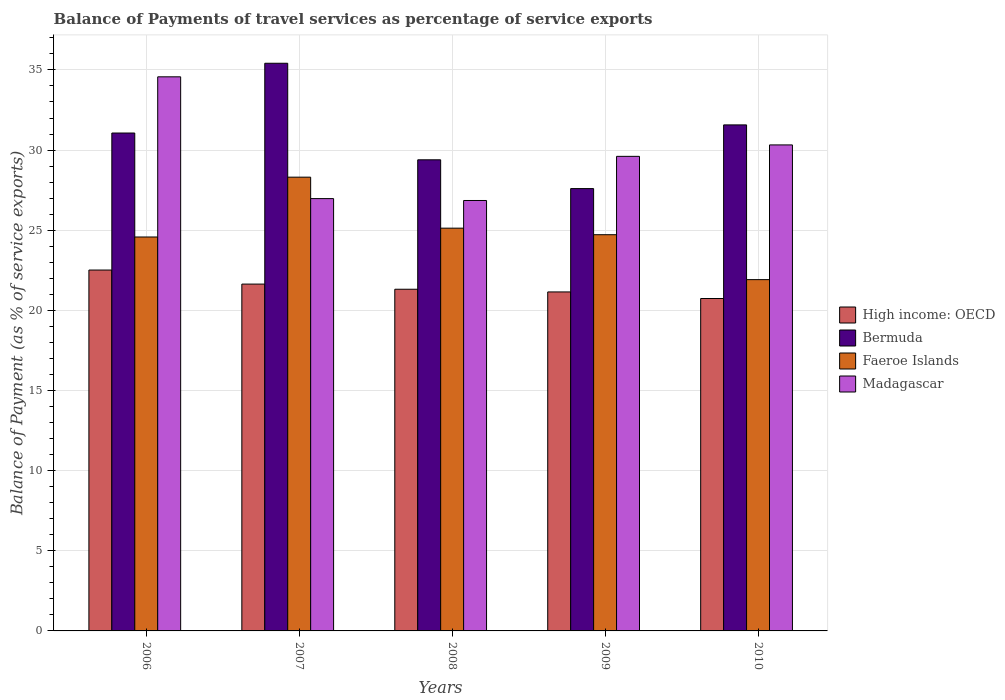How many groups of bars are there?
Provide a succinct answer. 5. What is the balance of payments of travel services in High income: OECD in 2008?
Your response must be concise. 21.32. Across all years, what is the maximum balance of payments of travel services in Madagascar?
Offer a very short reply. 34.57. Across all years, what is the minimum balance of payments of travel services in Faeroe Islands?
Ensure brevity in your answer.  21.92. In which year was the balance of payments of travel services in Bermuda maximum?
Give a very brief answer. 2007. In which year was the balance of payments of travel services in Faeroe Islands minimum?
Your answer should be compact. 2010. What is the total balance of payments of travel services in Faeroe Islands in the graph?
Make the answer very short. 124.65. What is the difference between the balance of payments of travel services in Bermuda in 2008 and that in 2010?
Provide a succinct answer. -2.18. What is the difference between the balance of payments of travel services in Bermuda in 2007 and the balance of payments of travel services in Faeroe Islands in 2009?
Your answer should be compact. 10.7. What is the average balance of payments of travel services in High income: OECD per year?
Your response must be concise. 21.47. In the year 2007, what is the difference between the balance of payments of travel services in Bermuda and balance of payments of travel services in Madagascar?
Make the answer very short. 8.44. What is the ratio of the balance of payments of travel services in Bermuda in 2006 to that in 2009?
Ensure brevity in your answer.  1.13. What is the difference between the highest and the second highest balance of payments of travel services in Madagascar?
Make the answer very short. 4.25. What is the difference between the highest and the lowest balance of payments of travel services in High income: OECD?
Provide a succinct answer. 1.78. In how many years, is the balance of payments of travel services in Faeroe Islands greater than the average balance of payments of travel services in Faeroe Islands taken over all years?
Your response must be concise. 2. What does the 3rd bar from the left in 2006 represents?
Provide a succinct answer. Faeroe Islands. What does the 1st bar from the right in 2006 represents?
Keep it short and to the point. Madagascar. How many bars are there?
Offer a very short reply. 20. How many years are there in the graph?
Offer a terse response. 5. Does the graph contain any zero values?
Ensure brevity in your answer.  No. Where does the legend appear in the graph?
Offer a very short reply. Center right. How many legend labels are there?
Make the answer very short. 4. What is the title of the graph?
Your answer should be compact. Balance of Payments of travel services as percentage of service exports. Does "Maldives" appear as one of the legend labels in the graph?
Your answer should be very brief. No. What is the label or title of the X-axis?
Give a very brief answer. Years. What is the label or title of the Y-axis?
Keep it short and to the point. Balance of Payment (as % of service exports). What is the Balance of Payment (as % of service exports) of High income: OECD in 2006?
Make the answer very short. 22.52. What is the Balance of Payment (as % of service exports) of Bermuda in 2006?
Ensure brevity in your answer.  31.06. What is the Balance of Payment (as % of service exports) of Faeroe Islands in 2006?
Provide a succinct answer. 24.58. What is the Balance of Payment (as % of service exports) of Madagascar in 2006?
Ensure brevity in your answer.  34.57. What is the Balance of Payment (as % of service exports) in High income: OECD in 2007?
Your answer should be compact. 21.64. What is the Balance of Payment (as % of service exports) of Bermuda in 2007?
Your response must be concise. 35.42. What is the Balance of Payment (as % of service exports) of Faeroe Islands in 2007?
Offer a very short reply. 28.31. What is the Balance of Payment (as % of service exports) of Madagascar in 2007?
Your answer should be very brief. 26.97. What is the Balance of Payment (as % of service exports) of High income: OECD in 2008?
Give a very brief answer. 21.32. What is the Balance of Payment (as % of service exports) in Bermuda in 2008?
Keep it short and to the point. 29.39. What is the Balance of Payment (as % of service exports) of Faeroe Islands in 2008?
Your answer should be very brief. 25.13. What is the Balance of Payment (as % of service exports) of Madagascar in 2008?
Your response must be concise. 26.86. What is the Balance of Payment (as % of service exports) of High income: OECD in 2009?
Offer a terse response. 21.15. What is the Balance of Payment (as % of service exports) of Bermuda in 2009?
Make the answer very short. 27.6. What is the Balance of Payment (as % of service exports) in Faeroe Islands in 2009?
Ensure brevity in your answer.  24.72. What is the Balance of Payment (as % of service exports) of Madagascar in 2009?
Your response must be concise. 29.61. What is the Balance of Payment (as % of service exports) of High income: OECD in 2010?
Keep it short and to the point. 20.74. What is the Balance of Payment (as % of service exports) in Bermuda in 2010?
Your response must be concise. 31.57. What is the Balance of Payment (as % of service exports) of Faeroe Islands in 2010?
Your response must be concise. 21.92. What is the Balance of Payment (as % of service exports) of Madagascar in 2010?
Provide a succinct answer. 30.32. Across all years, what is the maximum Balance of Payment (as % of service exports) in High income: OECD?
Make the answer very short. 22.52. Across all years, what is the maximum Balance of Payment (as % of service exports) in Bermuda?
Your response must be concise. 35.42. Across all years, what is the maximum Balance of Payment (as % of service exports) of Faeroe Islands?
Offer a very short reply. 28.31. Across all years, what is the maximum Balance of Payment (as % of service exports) in Madagascar?
Ensure brevity in your answer.  34.57. Across all years, what is the minimum Balance of Payment (as % of service exports) of High income: OECD?
Ensure brevity in your answer.  20.74. Across all years, what is the minimum Balance of Payment (as % of service exports) in Bermuda?
Provide a succinct answer. 27.6. Across all years, what is the minimum Balance of Payment (as % of service exports) in Faeroe Islands?
Give a very brief answer. 21.92. Across all years, what is the minimum Balance of Payment (as % of service exports) in Madagascar?
Provide a short and direct response. 26.86. What is the total Balance of Payment (as % of service exports) in High income: OECD in the graph?
Make the answer very short. 107.36. What is the total Balance of Payment (as % of service exports) in Bermuda in the graph?
Make the answer very short. 155.04. What is the total Balance of Payment (as % of service exports) in Faeroe Islands in the graph?
Ensure brevity in your answer.  124.65. What is the total Balance of Payment (as % of service exports) of Madagascar in the graph?
Ensure brevity in your answer.  148.33. What is the difference between the Balance of Payment (as % of service exports) in High income: OECD in 2006 and that in 2007?
Give a very brief answer. 0.88. What is the difference between the Balance of Payment (as % of service exports) in Bermuda in 2006 and that in 2007?
Offer a terse response. -4.35. What is the difference between the Balance of Payment (as % of service exports) in Faeroe Islands in 2006 and that in 2007?
Your answer should be compact. -3.73. What is the difference between the Balance of Payment (as % of service exports) of Madagascar in 2006 and that in 2007?
Provide a succinct answer. 7.6. What is the difference between the Balance of Payment (as % of service exports) of High income: OECD in 2006 and that in 2008?
Provide a succinct answer. 1.2. What is the difference between the Balance of Payment (as % of service exports) of Bermuda in 2006 and that in 2008?
Your answer should be very brief. 1.67. What is the difference between the Balance of Payment (as % of service exports) of Faeroe Islands in 2006 and that in 2008?
Provide a short and direct response. -0.55. What is the difference between the Balance of Payment (as % of service exports) in Madagascar in 2006 and that in 2008?
Offer a terse response. 7.72. What is the difference between the Balance of Payment (as % of service exports) in High income: OECD in 2006 and that in 2009?
Give a very brief answer. 1.37. What is the difference between the Balance of Payment (as % of service exports) of Bermuda in 2006 and that in 2009?
Give a very brief answer. 3.47. What is the difference between the Balance of Payment (as % of service exports) in Faeroe Islands in 2006 and that in 2009?
Offer a very short reply. -0.14. What is the difference between the Balance of Payment (as % of service exports) in Madagascar in 2006 and that in 2009?
Your response must be concise. 4.96. What is the difference between the Balance of Payment (as % of service exports) of High income: OECD in 2006 and that in 2010?
Provide a succinct answer. 1.78. What is the difference between the Balance of Payment (as % of service exports) in Bermuda in 2006 and that in 2010?
Your response must be concise. -0.51. What is the difference between the Balance of Payment (as % of service exports) in Faeroe Islands in 2006 and that in 2010?
Your answer should be very brief. 2.66. What is the difference between the Balance of Payment (as % of service exports) in Madagascar in 2006 and that in 2010?
Offer a very short reply. 4.25. What is the difference between the Balance of Payment (as % of service exports) in High income: OECD in 2007 and that in 2008?
Keep it short and to the point. 0.32. What is the difference between the Balance of Payment (as % of service exports) of Bermuda in 2007 and that in 2008?
Make the answer very short. 6.02. What is the difference between the Balance of Payment (as % of service exports) in Faeroe Islands in 2007 and that in 2008?
Offer a terse response. 3.18. What is the difference between the Balance of Payment (as % of service exports) of Madagascar in 2007 and that in 2008?
Make the answer very short. 0.12. What is the difference between the Balance of Payment (as % of service exports) of High income: OECD in 2007 and that in 2009?
Offer a very short reply. 0.49. What is the difference between the Balance of Payment (as % of service exports) of Bermuda in 2007 and that in 2009?
Make the answer very short. 7.82. What is the difference between the Balance of Payment (as % of service exports) of Faeroe Islands in 2007 and that in 2009?
Keep it short and to the point. 3.59. What is the difference between the Balance of Payment (as % of service exports) in Madagascar in 2007 and that in 2009?
Your answer should be very brief. -2.64. What is the difference between the Balance of Payment (as % of service exports) in High income: OECD in 2007 and that in 2010?
Offer a terse response. 0.9. What is the difference between the Balance of Payment (as % of service exports) in Bermuda in 2007 and that in 2010?
Keep it short and to the point. 3.85. What is the difference between the Balance of Payment (as % of service exports) in Faeroe Islands in 2007 and that in 2010?
Provide a succinct answer. 6.39. What is the difference between the Balance of Payment (as % of service exports) of Madagascar in 2007 and that in 2010?
Offer a very short reply. -3.35. What is the difference between the Balance of Payment (as % of service exports) in High income: OECD in 2008 and that in 2009?
Provide a succinct answer. 0.17. What is the difference between the Balance of Payment (as % of service exports) in Bermuda in 2008 and that in 2009?
Your answer should be very brief. 1.8. What is the difference between the Balance of Payment (as % of service exports) of Faeroe Islands in 2008 and that in 2009?
Offer a very short reply. 0.41. What is the difference between the Balance of Payment (as % of service exports) in Madagascar in 2008 and that in 2009?
Offer a very short reply. -2.75. What is the difference between the Balance of Payment (as % of service exports) of High income: OECD in 2008 and that in 2010?
Your answer should be compact. 0.58. What is the difference between the Balance of Payment (as % of service exports) of Bermuda in 2008 and that in 2010?
Offer a very short reply. -2.18. What is the difference between the Balance of Payment (as % of service exports) in Faeroe Islands in 2008 and that in 2010?
Your answer should be compact. 3.21. What is the difference between the Balance of Payment (as % of service exports) of Madagascar in 2008 and that in 2010?
Make the answer very short. -3.47. What is the difference between the Balance of Payment (as % of service exports) in High income: OECD in 2009 and that in 2010?
Your answer should be very brief. 0.41. What is the difference between the Balance of Payment (as % of service exports) in Bermuda in 2009 and that in 2010?
Make the answer very short. -3.97. What is the difference between the Balance of Payment (as % of service exports) in Faeroe Islands in 2009 and that in 2010?
Ensure brevity in your answer.  2.8. What is the difference between the Balance of Payment (as % of service exports) in Madagascar in 2009 and that in 2010?
Your response must be concise. -0.71. What is the difference between the Balance of Payment (as % of service exports) in High income: OECD in 2006 and the Balance of Payment (as % of service exports) in Bermuda in 2007?
Provide a succinct answer. -12.9. What is the difference between the Balance of Payment (as % of service exports) in High income: OECD in 2006 and the Balance of Payment (as % of service exports) in Faeroe Islands in 2007?
Offer a very short reply. -5.79. What is the difference between the Balance of Payment (as % of service exports) in High income: OECD in 2006 and the Balance of Payment (as % of service exports) in Madagascar in 2007?
Offer a very short reply. -4.46. What is the difference between the Balance of Payment (as % of service exports) in Bermuda in 2006 and the Balance of Payment (as % of service exports) in Faeroe Islands in 2007?
Make the answer very short. 2.75. What is the difference between the Balance of Payment (as % of service exports) in Bermuda in 2006 and the Balance of Payment (as % of service exports) in Madagascar in 2007?
Offer a terse response. 4.09. What is the difference between the Balance of Payment (as % of service exports) of Faeroe Islands in 2006 and the Balance of Payment (as % of service exports) of Madagascar in 2007?
Offer a very short reply. -2.4. What is the difference between the Balance of Payment (as % of service exports) of High income: OECD in 2006 and the Balance of Payment (as % of service exports) of Bermuda in 2008?
Keep it short and to the point. -6.88. What is the difference between the Balance of Payment (as % of service exports) in High income: OECD in 2006 and the Balance of Payment (as % of service exports) in Faeroe Islands in 2008?
Offer a very short reply. -2.61. What is the difference between the Balance of Payment (as % of service exports) in High income: OECD in 2006 and the Balance of Payment (as % of service exports) in Madagascar in 2008?
Your response must be concise. -4.34. What is the difference between the Balance of Payment (as % of service exports) of Bermuda in 2006 and the Balance of Payment (as % of service exports) of Faeroe Islands in 2008?
Your answer should be compact. 5.94. What is the difference between the Balance of Payment (as % of service exports) of Bermuda in 2006 and the Balance of Payment (as % of service exports) of Madagascar in 2008?
Provide a succinct answer. 4.21. What is the difference between the Balance of Payment (as % of service exports) in Faeroe Islands in 2006 and the Balance of Payment (as % of service exports) in Madagascar in 2008?
Your response must be concise. -2.28. What is the difference between the Balance of Payment (as % of service exports) of High income: OECD in 2006 and the Balance of Payment (as % of service exports) of Bermuda in 2009?
Provide a short and direct response. -5.08. What is the difference between the Balance of Payment (as % of service exports) of High income: OECD in 2006 and the Balance of Payment (as % of service exports) of Faeroe Islands in 2009?
Your answer should be very brief. -2.2. What is the difference between the Balance of Payment (as % of service exports) of High income: OECD in 2006 and the Balance of Payment (as % of service exports) of Madagascar in 2009?
Your answer should be compact. -7.09. What is the difference between the Balance of Payment (as % of service exports) of Bermuda in 2006 and the Balance of Payment (as % of service exports) of Faeroe Islands in 2009?
Keep it short and to the point. 6.34. What is the difference between the Balance of Payment (as % of service exports) in Bermuda in 2006 and the Balance of Payment (as % of service exports) in Madagascar in 2009?
Make the answer very short. 1.46. What is the difference between the Balance of Payment (as % of service exports) of Faeroe Islands in 2006 and the Balance of Payment (as % of service exports) of Madagascar in 2009?
Ensure brevity in your answer.  -5.03. What is the difference between the Balance of Payment (as % of service exports) of High income: OECD in 2006 and the Balance of Payment (as % of service exports) of Bermuda in 2010?
Provide a succinct answer. -9.05. What is the difference between the Balance of Payment (as % of service exports) in High income: OECD in 2006 and the Balance of Payment (as % of service exports) in Faeroe Islands in 2010?
Provide a short and direct response. 0.6. What is the difference between the Balance of Payment (as % of service exports) of High income: OECD in 2006 and the Balance of Payment (as % of service exports) of Madagascar in 2010?
Offer a terse response. -7.81. What is the difference between the Balance of Payment (as % of service exports) of Bermuda in 2006 and the Balance of Payment (as % of service exports) of Faeroe Islands in 2010?
Keep it short and to the point. 9.15. What is the difference between the Balance of Payment (as % of service exports) of Bermuda in 2006 and the Balance of Payment (as % of service exports) of Madagascar in 2010?
Provide a short and direct response. 0.74. What is the difference between the Balance of Payment (as % of service exports) of Faeroe Islands in 2006 and the Balance of Payment (as % of service exports) of Madagascar in 2010?
Your answer should be compact. -5.74. What is the difference between the Balance of Payment (as % of service exports) in High income: OECD in 2007 and the Balance of Payment (as % of service exports) in Bermuda in 2008?
Offer a terse response. -7.75. What is the difference between the Balance of Payment (as % of service exports) of High income: OECD in 2007 and the Balance of Payment (as % of service exports) of Faeroe Islands in 2008?
Offer a terse response. -3.49. What is the difference between the Balance of Payment (as % of service exports) of High income: OECD in 2007 and the Balance of Payment (as % of service exports) of Madagascar in 2008?
Make the answer very short. -5.22. What is the difference between the Balance of Payment (as % of service exports) of Bermuda in 2007 and the Balance of Payment (as % of service exports) of Faeroe Islands in 2008?
Ensure brevity in your answer.  10.29. What is the difference between the Balance of Payment (as % of service exports) in Bermuda in 2007 and the Balance of Payment (as % of service exports) in Madagascar in 2008?
Make the answer very short. 8.56. What is the difference between the Balance of Payment (as % of service exports) of Faeroe Islands in 2007 and the Balance of Payment (as % of service exports) of Madagascar in 2008?
Keep it short and to the point. 1.46. What is the difference between the Balance of Payment (as % of service exports) in High income: OECD in 2007 and the Balance of Payment (as % of service exports) in Bermuda in 2009?
Give a very brief answer. -5.96. What is the difference between the Balance of Payment (as % of service exports) in High income: OECD in 2007 and the Balance of Payment (as % of service exports) in Faeroe Islands in 2009?
Ensure brevity in your answer.  -3.08. What is the difference between the Balance of Payment (as % of service exports) in High income: OECD in 2007 and the Balance of Payment (as % of service exports) in Madagascar in 2009?
Your answer should be very brief. -7.97. What is the difference between the Balance of Payment (as % of service exports) of Bermuda in 2007 and the Balance of Payment (as % of service exports) of Faeroe Islands in 2009?
Give a very brief answer. 10.7. What is the difference between the Balance of Payment (as % of service exports) of Bermuda in 2007 and the Balance of Payment (as % of service exports) of Madagascar in 2009?
Your response must be concise. 5.81. What is the difference between the Balance of Payment (as % of service exports) in Faeroe Islands in 2007 and the Balance of Payment (as % of service exports) in Madagascar in 2009?
Make the answer very short. -1.3. What is the difference between the Balance of Payment (as % of service exports) of High income: OECD in 2007 and the Balance of Payment (as % of service exports) of Bermuda in 2010?
Keep it short and to the point. -9.93. What is the difference between the Balance of Payment (as % of service exports) of High income: OECD in 2007 and the Balance of Payment (as % of service exports) of Faeroe Islands in 2010?
Your answer should be very brief. -0.28. What is the difference between the Balance of Payment (as % of service exports) of High income: OECD in 2007 and the Balance of Payment (as % of service exports) of Madagascar in 2010?
Your answer should be compact. -8.68. What is the difference between the Balance of Payment (as % of service exports) in Bermuda in 2007 and the Balance of Payment (as % of service exports) in Madagascar in 2010?
Make the answer very short. 5.09. What is the difference between the Balance of Payment (as % of service exports) in Faeroe Islands in 2007 and the Balance of Payment (as % of service exports) in Madagascar in 2010?
Your answer should be compact. -2.01. What is the difference between the Balance of Payment (as % of service exports) in High income: OECD in 2008 and the Balance of Payment (as % of service exports) in Bermuda in 2009?
Make the answer very short. -6.28. What is the difference between the Balance of Payment (as % of service exports) in High income: OECD in 2008 and the Balance of Payment (as % of service exports) in Faeroe Islands in 2009?
Offer a terse response. -3.4. What is the difference between the Balance of Payment (as % of service exports) in High income: OECD in 2008 and the Balance of Payment (as % of service exports) in Madagascar in 2009?
Ensure brevity in your answer.  -8.29. What is the difference between the Balance of Payment (as % of service exports) in Bermuda in 2008 and the Balance of Payment (as % of service exports) in Faeroe Islands in 2009?
Your answer should be very brief. 4.67. What is the difference between the Balance of Payment (as % of service exports) in Bermuda in 2008 and the Balance of Payment (as % of service exports) in Madagascar in 2009?
Give a very brief answer. -0.21. What is the difference between the Balance of Payment (as % of service exports) of Faeroe Islands in 2008 and the Balance of Payment (as % of service exports) of Madagascar in 2009?
Make the answer very short. -4.48. What is the difference between the Balance of Payment (as % of service exports) in High income: OECD in 2008 and the Balance of Payment (as % of service exports) in Bermuda in 2010?
Ensure brevity in your answer.  -10.25. What is the difference between the Balance of Payment (as % of service exports) of High income: OECD in 2008 and the Balance of Payment (as % of service exports) of Faeroe Islands in 2010?
Your answer should be compact. -0.6. What is the difference between the Balance of Payment (as % of service exports) of High income: OECD in 2008 and the Balance of Payment (as % of service exports) of Madagascar in 2010?
Offer a terse response. -9.01. What is the difference between the Balance of Payment (as % of service exports) of Bermuda in 2008 and the Balance of Payment (as % of service exports) of Faeroe Islands in 2010?
Offer a very short reply. 7.48. What is the difference between the Balance of Payment (as % of service exports) of Bermuda in 2008 and the Balance of Payment (as % of service exports) of Madagascar in 2010?
Provide a short and direct response. -0.93. What is the difference between the Balance of Payment (as % of service exports) in Faeroe Islands in 2008 and the Balance of Payment (as % of service exports) in Madagascar in 2010?
Ensure brevity in your answer.  -5.19. What is the difference between the Balance of Payment (as % of service exports) in High income: OECD in 2009 and the Balance of Payment (as % of service exports) in Bermuda in 2010?
Ensure brevity in your answer.  -10.42. What is the difference between the Balance of Payment (as % of service exports) of High income: OECD in 2009 and the Balance of Payment (as % of service exports) of Faeroe Islands in 2010?
Provide a short and direct response. -0.77. What is the difference between the Balance of Payment (as % of service exports) in High income: OECD in 2009 and the Balance of Payment (as % of service exports) in Madagascar in 2010?
Provide a short and direct response. -9.17. What is the difference between the Balance of Payment (as % of service exports) in Bermuda in 2009 and the Balance of Payment (as % of service exports) in Faeroe Islands in 2010?
Make the answer very short. 5.68. What is the difference between the Balance of Payment (as % of service exports) in Bermuda in 2009 and the Balance of Payment (as % of service exports) in Madagascar in 2010?
Ensure brevity in your answer.  -2.72. What is the difference between the Balance of Payment (as % of service exports) of Faeroe Islands in 2009 and the Balance of Payment (as % of service exports) of Madagascar in 2010?
Keep it short and to the point. -5.6. What is the average Balance of Payment (as % of service exports) of High income: OECD per year?
Ensure brevity in your answer.  21.47. What is the average Balance of Payment (as % of service exports) of Bermuda per year?
Ensure brevity in your answer.  31.01. What is the average Balance of Payment (as % of service exports) in Faeroe Islands per year?
Make the answer very short. 24.93. What is the average Balance of Payment (as % of service exports) of Madagascar per year?
Ensure brevity in your answer.  29.67. In the year 2006, what is the difference between the Balance of Payment (as % of service exports) of High income: OECD and Balance of Payment (as % of service exports) of Bermuda?
Keep it short and to the point. -8.55. In the year 2006, what is the difference between the Balance of Payment (as % of service exports) in High income: OECD and Balance of Payment (as % of service exports) in Faeroe Islands?
Make the answer very short. -2.06. In the year 2006, what is the difference between the Balance of Payment (as % of service exports) in High income: OECD and Balance of Payment (as % of service exports) in Madagascar?
Provide a short and direct response. -12.05. In the year 2006, what is the difference between the Balance of Payment (as % of service exports) of Bermuda and Balance of Payment (as % of service exports) of Faeroe Islands?
Ensure brevity in your answer.  6.49. In the year 2006, what is the difference between the Balance of Payment (as % of service exports) in Bermuda and Balance of Payment (as % of service exports) in Madagascar?
Give a very brief answer. -3.51. In the year 2006, what is the difference between the Balance of Payment (as % of service exports) of Faeroe Islands and Balance of Payment (as % of service exports) of Madagascar?
Provide a short and direct response. -9.99. In the year 2007, what is the difference between the Balance of Payment (as % of service exports) of High income: OECD and Balance of Payment (as % of service exports) of Bermuda?
Your answer should be very brief. -13.78. In the year 2007, what is the difference between the Balance of Payment (as % of service exports) of High income: OECD and Balance of Payment (as % of service exports) of Faeroe Islands?
Provide a succinct answer. -6.67. In the year 2007, what is the difference between the Balance of Payment (as % of service exports) in High income: OECD and Balance of Payment (as % of service exports) in Madagascar?
Make the answer very short. -5.33. In the year 2007, what is the difference between the Balance of Payment (as % of service exports) of Bermuda and Balance of Payment (as % of service exports) of Faeroe Islands?
Offer a terse response. 7.11. In the year 2007, what is the difference between the Balance of Payment (as % of service exports) of Bermuda and Balance of Payment (as % of service exports) of Madagascar?
Keep it short and to the point. 8.44. In the year 2007, what is the difference between the Balance of Payment (as % of service exports) in Faeroe Islands and Balance of Payment (as % of service exports) in Madagascar?
Your answer should be compact. 1.34. In the year 2008, what is the difference between the Balance of Payment (as % of service exports) of High income: OECD and Balance of Payment (as % of service exports) of Bermuda?
Ensure brevity in your answer.  -8.08. In the year 2008, what is the difference between the Balance of Payment (as % of service exports) of High income: OECD and Balance of Payment (as % of service exports) of Faeroe Islands?
Your answer should be compact. -3.81. In the year 2008, what is the difference between the Balance of Payment (as % of service exports) of High income: OECD and Balance of Payment (as % of service exports) of Madagascar?
Keep it short and to the point. -5.54. In the year 2008, what is the difference between the Balance of Payment (as % of service exports) of Bermuda and Balance of Payment (as % of service exports) of Faeroe Islands?
Your answer should be compact. 4.27. In the year 2008, what is the difference between the Balance of Payment (as % of service exports) of Bermuda and Balance of Payment (as % of service exports) of Madagascar?
Offer a terse response. 2.54. In the year 2008, what is the difference between the Balance of Payment (as % of service exports) of Faeroe Islands and Balance of Payment (as % of service exports) of Madagascar?
Give a very brief answer. -1.73. In the year 2009, what is the difference between the Balance of Payment (as % of service exports) of High income: OECD and Balance of Payment (as % of service exports) of Bermuda?
Your answer should be compact. -6.45. In the year 2009, what is the difference between the Balance of Payment (as % of service exports) of High income: OECD and Balance of Payment (as % of service exports) of Faeroe Islands?
Keep it short and to the point. -3.57. In the year 2009, what is the difference between the Balance of Payment (as % of service exports) of High income: OECD and Balance of Payment (as % of service exports) of Madagascar?
Provide a short and direct response. -8.46. In the year 2009, what is the difference between the Balance of Payment (as % of service exports) in Bermuda and Balance of Payment (as % of service exports) in Faeroe Islands?
Make the answer very short. 2.88. In the year 2009, what is the difference between the Balance of Payment (as % of service exports) in Bermuda and Balance of Payment (as % of service exports) in Madagascar?
Your response must be concise. -2.01. In the year 2009, what is the difference between the Balance of Payment (as % of service exports) in Faeroe Islands and Balance of Payment (as % of service exports) in Madagascar?
Offer a terse response. -4.89. In the year 2010, what is the difference between the Balance of Payment (as % of service exports) in High income: OECD and Balance of Payment (as % of service exports) in Bermuda?
Give a very brief answer. -10.83. In the year 2010, what is the difference between the Balance of Payment (as % of service exports) in High income: OECD and Balance of Payment (as % of service exports) in Faeroe Islands?
Your answer should be very brief. -1.18. In the year 2010, what is the difference between the Balance of Payment (as % of service exports) in High income: OECD and Balance of Payment (as % of service exports) in Madagascar?
Offer a very short reply. -9.58. In the year 2010, what is the difference between the Balance of Payment (as % of service exports) in Bermuda and Balance of Payment (as % of service exports) in Faeroe Islands?
Ensure brevity in your answer.  9.65. In the year 2010, what is the difference between the Balance of Payment (as % of service exports) of Bermuda and Balance of Payment (as % of service exports) of Madagascar?
Provide a succinct answer. 1.25. In the year 2010, what is the difference between the Balance of Payment (as % of service exports) in Faeroe Islands and Balance of Payment (as % of service exports) in Madagascar?
Give a very brief answer. -8.41. What is the ratio of the Balance of Payment (as % of service exports) in High income: OECD in 2006 to that in 2007?
Ensure brevity in your answer.  1.04. What is the ratio of the Balance of Payment (as % of service exports) in Bermuda in 2006 to that in 2007?
Your answer should be compact. 0.88. What is the ratio of the Balance of Payment (as % of service exports) of Faeroe Islands in 2006 to that in 2007?
Provide a succinct answer. 0.87. What is the ratio of the Balance of Payment (as % of service exports) of Madagascar in 2006 to that in 2007?
Make the answer very short. 1.28. What is the ratio of the Balance of Payment (as % of service exports) of High income: OECD in 2006 to that in 2008?
Offer a terse response. 1.06. What is the ratio of the Balance of Payment (as % of service exports) of Bermuda in 2006 to that in 2008?
Your answer should be compact. 1.06. What is the ratio of the Balance of Payment (as % of service exports) of Faeroe Islands in 2006 to that in 2008?
Provide a succinct answer. 0.98. What is the ratio of the Balance of Payment (as % of service exports) of Madagascar in 2006 to that in 2008?
Offer a terse response. 1.29. What is the ratio of the Balance of Payment (as % of service exports) of High income: OECD in 2006 to that in 2009?
Offer a very short reply. 1.06. What is the ratio of the Balance of Payment (as % of service exports) in Bermuda in 2006 to that in 2009?
Offer a very short reply. 1.13. What is the ratio of the Balance of Payment (as % of service exports) of Faeroe Islands in 2006 to that in 2009?
Provide a short and direct response. 0.99. What is the ratio of the Balance of Payment (as % of service exports) of Madagascar in 2006 to that in 2009?
Provide a succinct answer. 1.17. What is the ratio of the Balance of Payment (as % of service exports) in High income: OECD in 2006 to that in 2010?
Your response must be concise. 1.09. What is the ratio of the Balance of Payment (as % of service exports) in Bermuda in 2006 to that in 2010?
Keep it short and to the point. 0.98. What is the ratio of the Balance of Payment (as % of service exports) in Faeroe Islands in 2006 to that in 2010?
Keep it short and to the point. 1.12. What is the ratio of the Balance of Payment (as % of service exports) in Madagascar in 2006 to that in 2010?
Your answer should be compact. 1.14. What is the ratio of the Balance of Payment (as % of service exports) of High income: OECD in 2007 to that in 2008?
Ensure brevity in your answer.  1.02. What is the ratio of the Balance of Payment (as % of service exports) of Bermuda in 2007 to that in 2008?
Ensure brevity in your answer.  1.2. What is the ratio of the Balance of Payment (as % of service exports) of Faeroe Islands in 2007 to that in 2008?
Make the answer very short. 1.13. What is the ratio of the Balance of Payment (as % of service exports) of Madagascar in 2007 to that in 2008?
Offer a very short reply. 1. What is the ratio of the Balance of Payment (as % of service exports) in High income: OECD in 2007 to that in 2009?
Ensure brevity in your answer.  1.02. What is the ratio of the Balance of Payment (as % of service exports) in Bermuda in 2007 to that in 2009?
Your answer should be compact. 1.28. What is the ratio of the Balance of Payment (as % of service exports) in Faeroe Islands in 2007 to that in 2009?
Keep it short and to the point. 1.15. What is the ratio of the Balance of Payment (as % of service exports) in Madagascar in 2007 to that in 2009?
Your answer should be compact. 0.91. What is the ratio of the Balance of Payment (as % of service exports) of High income: OECD in 2007 to that in 2010?
Provide a short and direct response. 1.04. What is the ratio of the Balance of Payment (as % of service exports) of Bermuda in 2007 to that in 2010?
Provide a succinct answer. 1.12. What is the ratio of the Balance of Payment (as % of service exports) of Faeroe Islands in 2007 to that in 2010?
Your answer should be compact. 1.29. What is the ratio of the Balance of Payment (as % of service exports) of Madagascar in 2007 to that in 2010?
Give a very brief answer. 0.89. What is the ratio of the Balance of Payment (as % of service exports) of High income: OECD in 2008 to that in 2009?
Make the answer very short. 1.01. What is the ratio of the Balance of Payment (as % of service exports) in Bermuda in 2008 to that in 2009?
Provide a succinct answer. 1.07. What is the ratio of the Balance of Payment (as % of service exports) of Faeroe Islands in 2008 to that in 2009?
Ensure brevity in your answer.  1.02. What is the ratio of the Balance of Payment (as % of service exports) of Madagascar in 2008 to that in 2009?
Offer a very short reply. 0.91. What is the ratio of the Balance of Payment (as % of service exports) in High income: OECD in 2008 to that in 2010?
Your answer should be compact. 1.03. What is the ratio of the Balance of Payment (as % of service exports) of Faeroe Islands in 2008 to that in 2010?
Offer a terse response. 1.15. What is the ratio of the Balance of Payment (as % of service exports) of Madagascar in 2008 to that in 2010?
Provide a short and direct response. 0.89. What is the ratio of the Balance of Payment (as % of service exports) of High income: OECD in 2009 to that in 2010?
Your answer should be very brief. 1.02. What is the ratio of the Balance of Payment (as % of service exports) in Bermuda in 2009 to that in 2010?
Make the answer very short. 0.87. What is the ratio of the Balance of Payment (as % of service exports) in Faeroe Islands in 2009 to that in 2010?
Give a very brief answer. 1.13. What is the ratio of the Balance of Payment (as % of service exports) in Madagascar in 2009 to that in 2010?
Keep it short and to the point. 0.98. What is the difference between the highest and the second highest Balance of Payment (as % of service exports) of High income: OECD?
Offer a very short reply. 0.88. What is the difference between the highest and the second highest Balance of Payment (as % of service exports) of Bermuda?
Your answer should be very brief. 3.85. What is the difference between the highest and the second highest Balance of Payment (as % of service exports) of Faeroe Islands?
Offer a terse response. 3.18. What is the difference between the highest and the second highest Balance of Payment (as % of service exports) in Madagascar?
Provide a short and direct response. 4.25. What is the difference between the highest and the lowest Balance of Payment (as % of service exports) in High income: OECD?
Your answer should be compact. 1.78. What is the difference between the highest and the lowest Balance of Payment (as % of service exports) in Bermuda?
Provide a short and direct response. 7.82. What is the difference between the highest and the lowest Balance of Payment (as % of service exports) of Faeroe Islands?
Your answer should be very brief. 6.39. What is the difference between the highest and the lowest Balance of Payment (as % of service exports) of Madagascar?
Your answer should be compact. 7.72. 